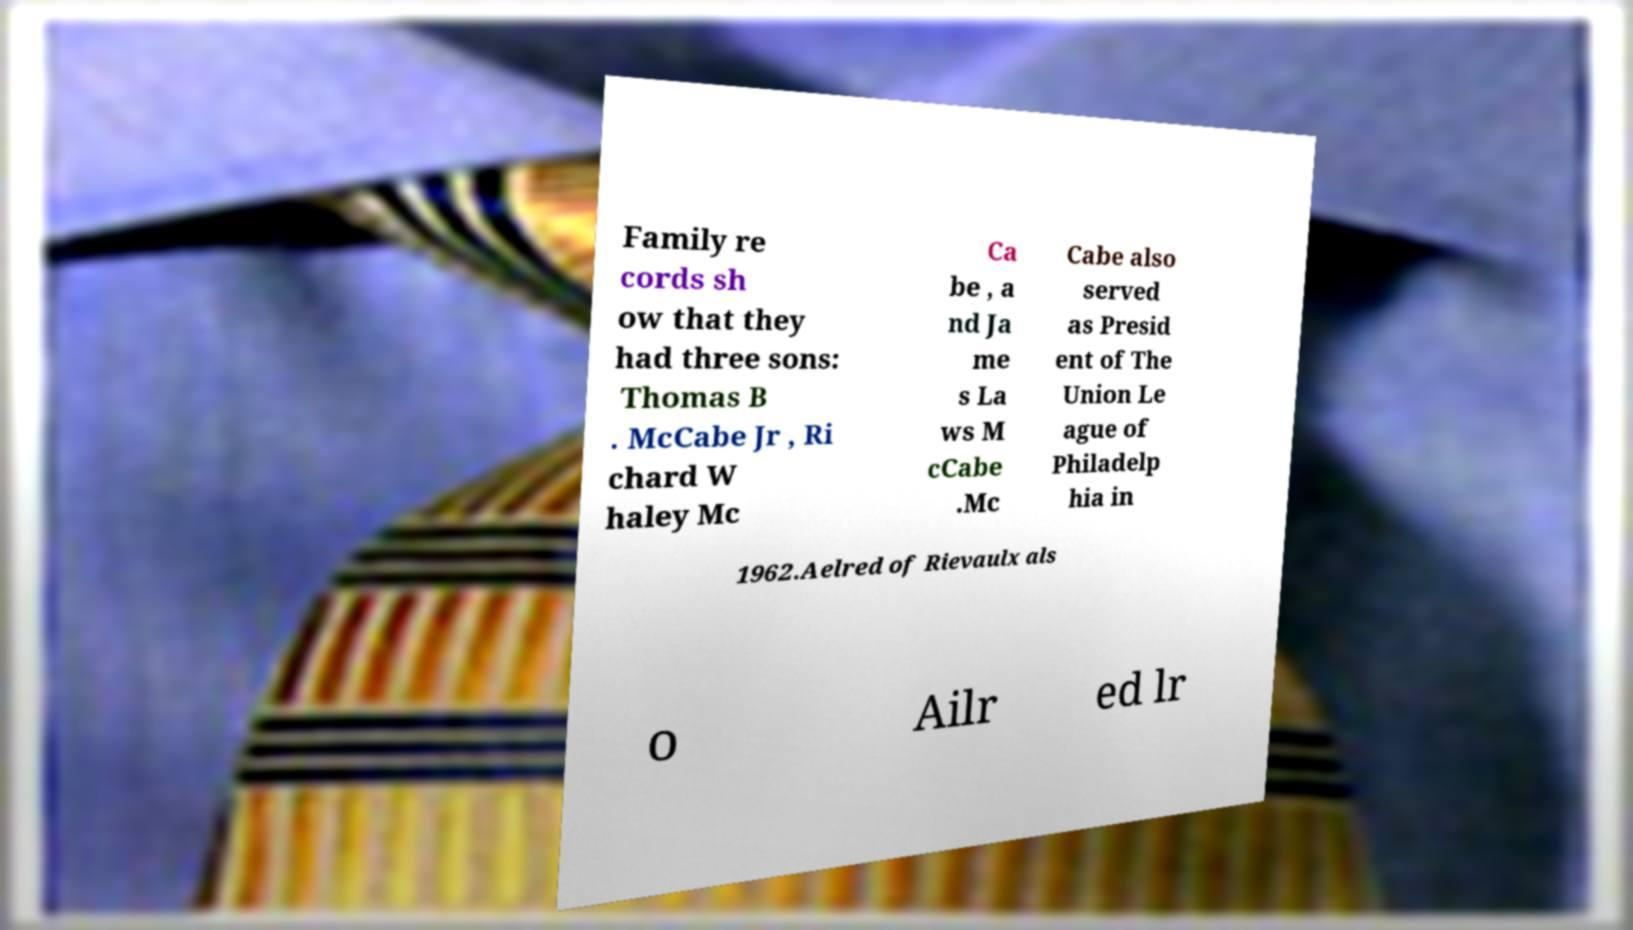Please identify and transcribe the text found in this image. Family re cords sh ow that they had three sons: Thomas B . McCabe Jr , Ri chard W haley Mc Ca be , a nd Ja me s La ws M cCabe .Mc Cabe also served as Presid ent of The Union Le ague of Philadelp hia in 1962.Aelred of Rievaulx als o Ailr ed lr 